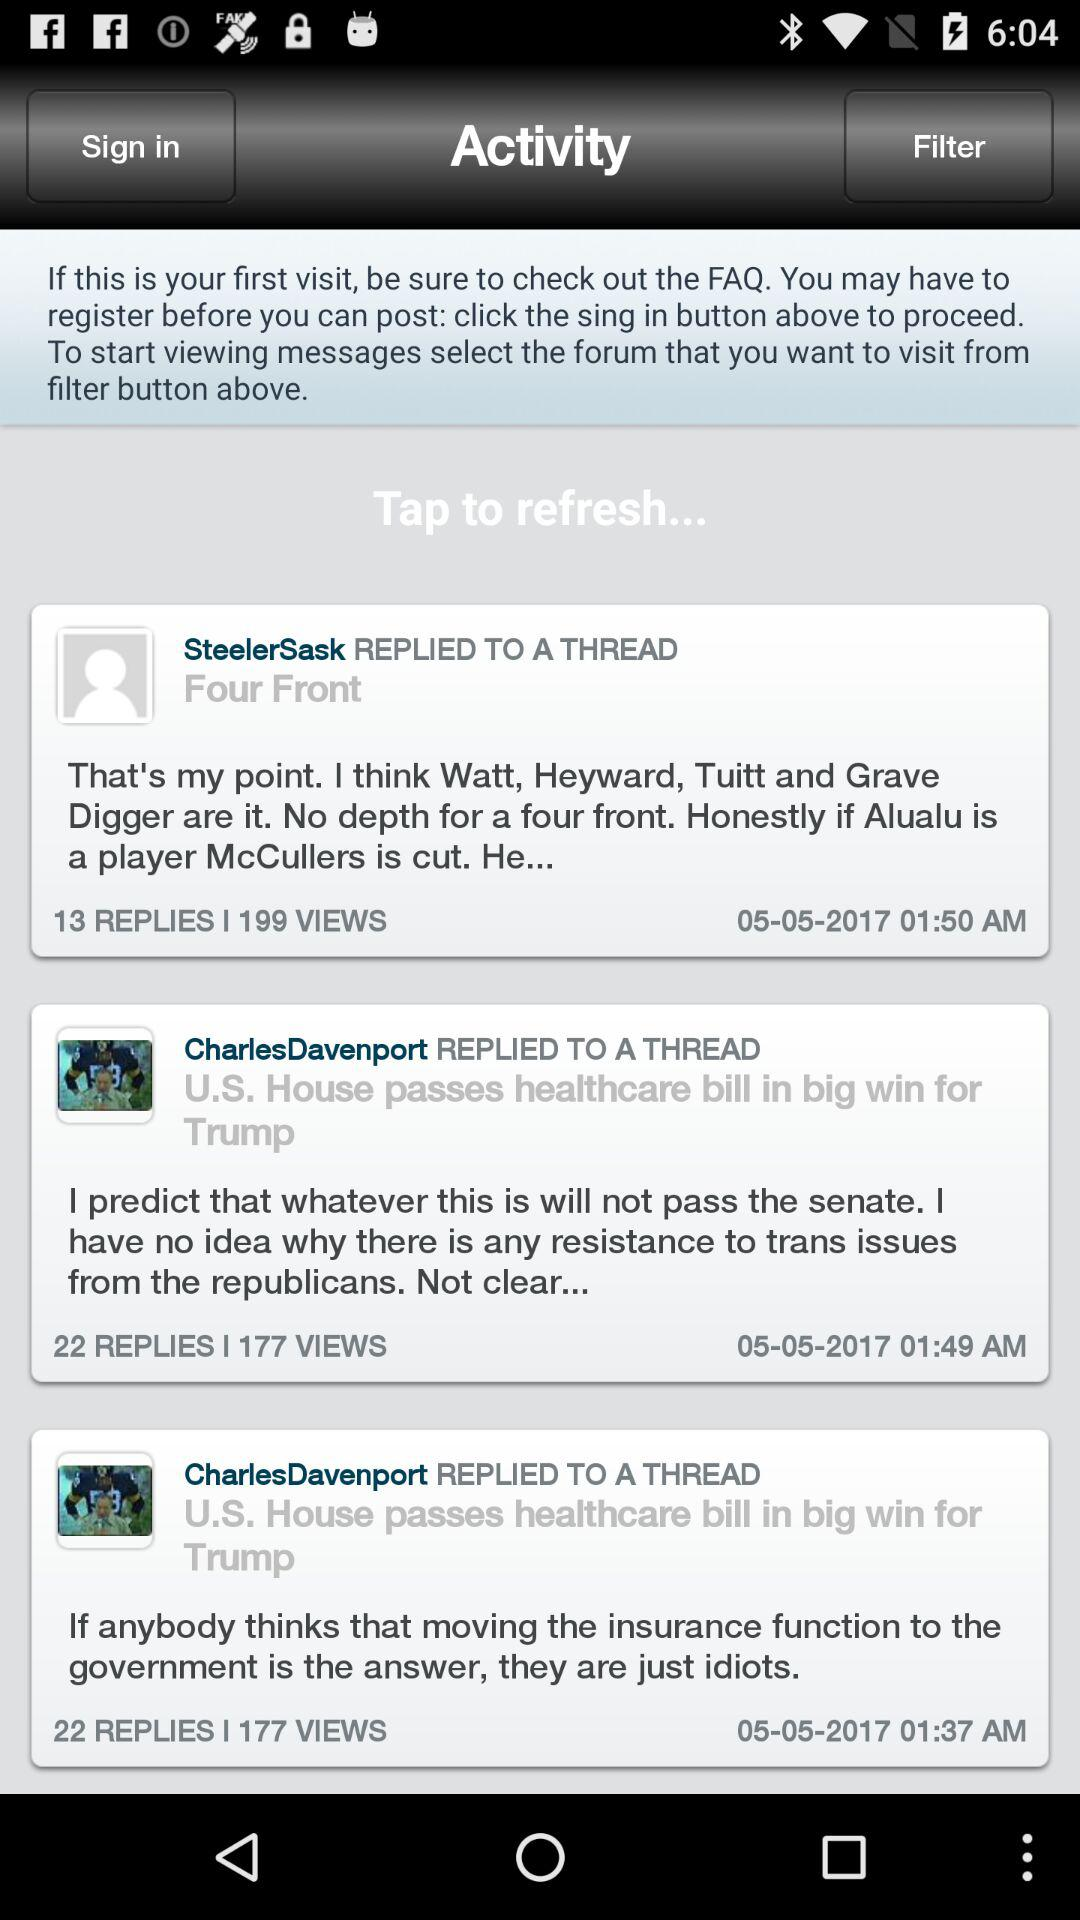How many replies on CharlesDavenport's post? There are 22 replies. 